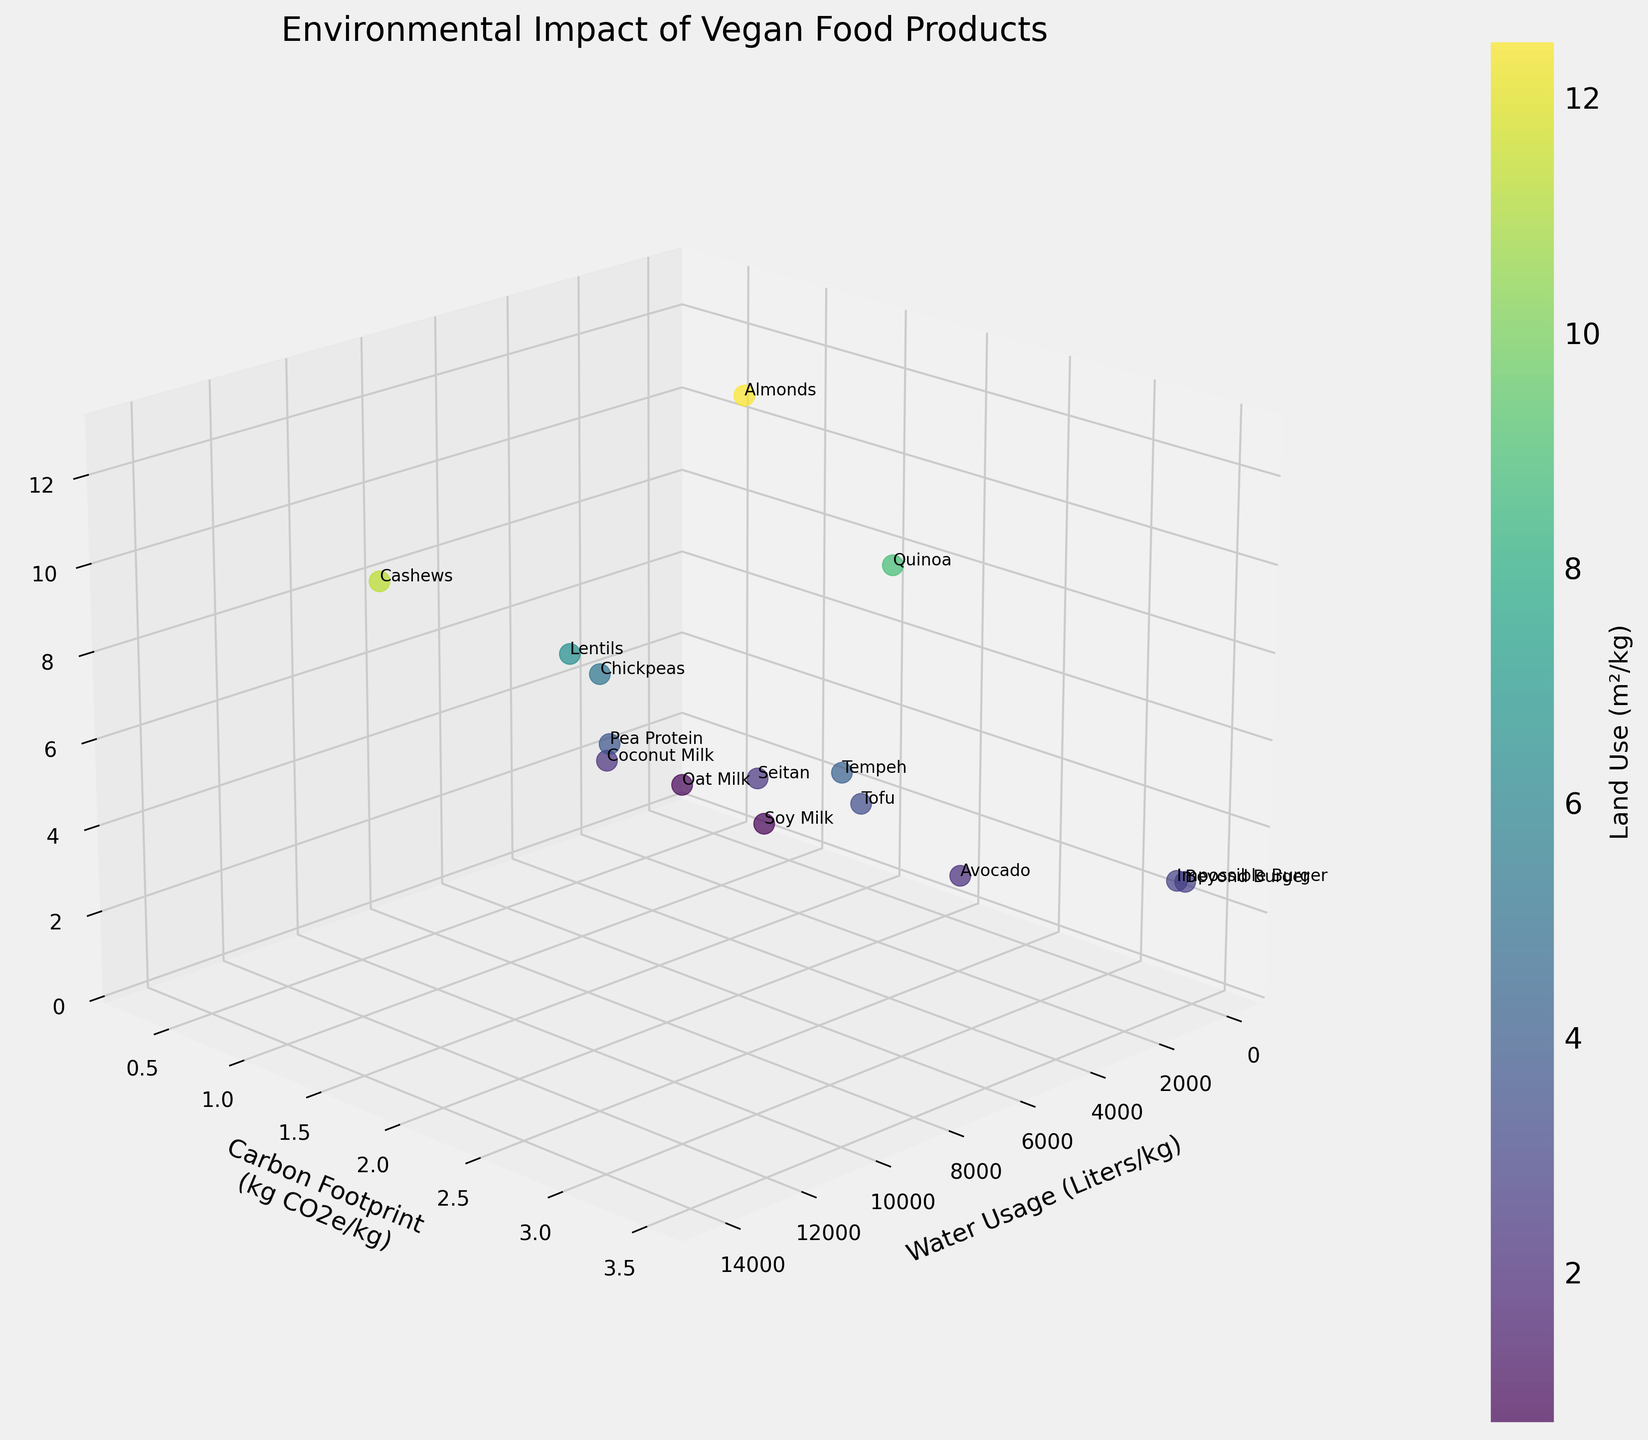what is the food product with the highest water usage? To find the food product with the highest water usage, look for the point furthest along the x-axis. The legend helps identify the product. In this case, it's Cashews with 14,218 liters/kg.
Answer: Cashews What is the range of carbon footprints for the food products? To determine the range, locate the minimum and maximum y-axis values for the carbon footprint. The minimum is 0.3 (Oat Milk), and the maximum is 3.5 (Beyond Burger and Impossible Burger).
Answer: 0.3 to 3.5 kg CO2e/kg Which food product has the least land use? The product with the least land use will be nearest on the z-axis. From observation, Soy Milk uses the least land at 0.7 m²/kg.
Answer: Soy Milk Which product has a similar carbon footprint but different water usage and land use compared to Tofu? Check the position of Tofu and see which other point is aligned along the y-axis but differs on the x and z-axes. Tempeh has the same carbon footprint (2.0 kg CO2e/kg) but different water usage and land use.
Answer: Tempeh Out of Oat Milk and Almonds, which consumes less land? Compare their z-axis positions. Oat Milk shows less land use at 0.8 m²/kg compared to Almonds at 12.5 m²/kg.
Answer: Oat Milk Which food products have a water usage between 1,000 and 3,000 liters/kg? Identify the points in the x-axis range between 1,000 and 3,000. Almonds (3,630), Tofu (2,523), Avocado (1,981), Seitan (1,405), and Coconut Milk (2,687) are included.
Answer: Tofu, Avocado, Seitan, Coconut Milk What's the average land usage of Lentils and Almonds? Add the land usage values of Lentils (6.4 m²/kg) and Almonds (12.5 m²/kg) and divide by 2: (6.4 + 12.5) / 2 = 9.45.
Answer: 9.45 m²/kg How many food products have a carbon footprint less than 1 kg CO2e/kg? Count the data points below the y-axis value of 1. There are five such points: Oat Milk, Lentils, Soy Milk, Pea Protein, and Chickpeas.
Answer: 5 